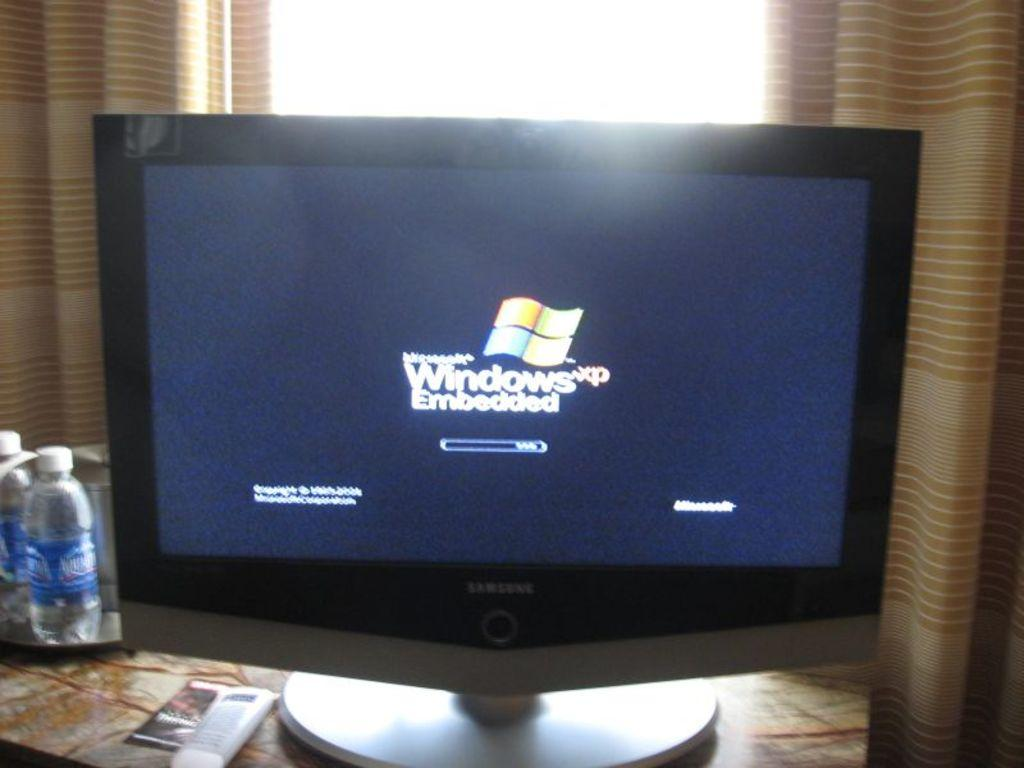What type of covering can be seen in the image? There is a curtain in the image. What objects are present that might contain liquid? There are bottles in the image. What might be used for displaying information or images? There is a screen in the image. What piece of furniture is visible in the image? There is a table in the image. Are there any rods visible in the image? There is no mention of rods in the provided facts, so we cannot determine if any are present in the image. Can you see a tramp in the image? There is no mention of a tramp in the provided facts, so we cannot determine if one is present in the image. 